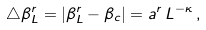<formula> <loc_0><loc_0><loc_500><loc_500>\triangle \beta _ { L } ^ { r } = \left | \beta _ { L } ^ { r } - \beta _ { c } \right | = a ^ { r } \, L ^ { - \kappa } \, ,</formula> 